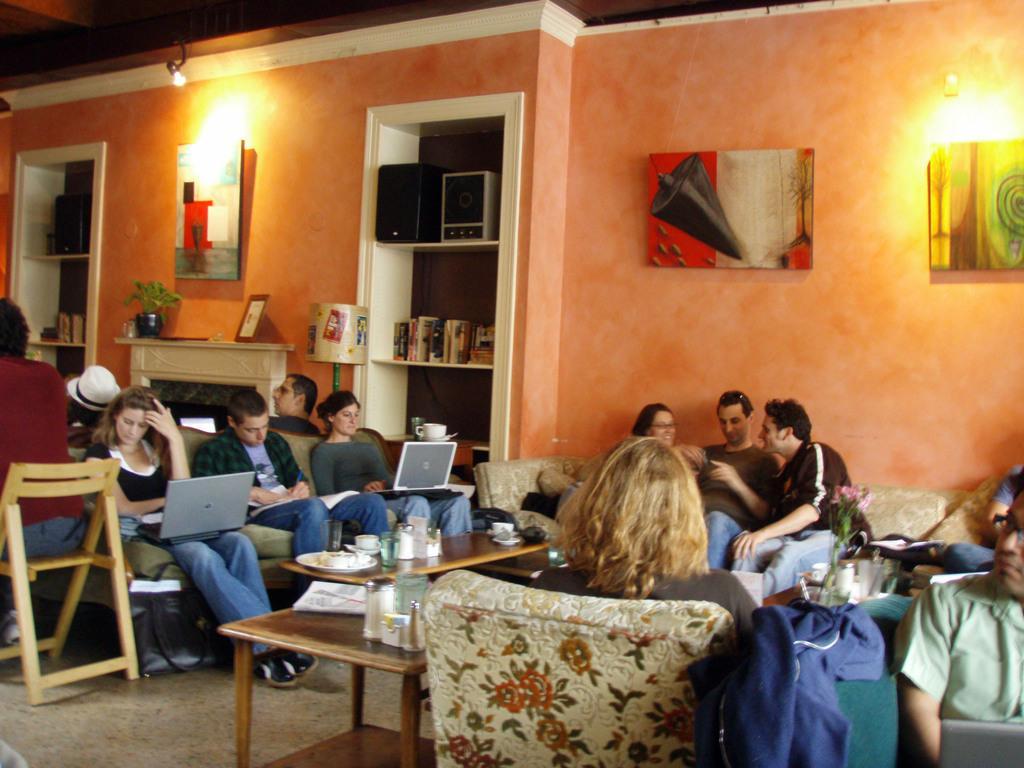Describe this image in one or two sentences. On the background of the picture we can see an orange wall. Here we can see cupboards, shelves where we can see few books, woofers arranged. This is a flower vase and few photo frames over a wall. This is a light. here we cans ee few persons sitting on the sofas and chairs and busy with their own works. This is a table and on the table we can see cups, plates, glasses. This is a floor carpet. 